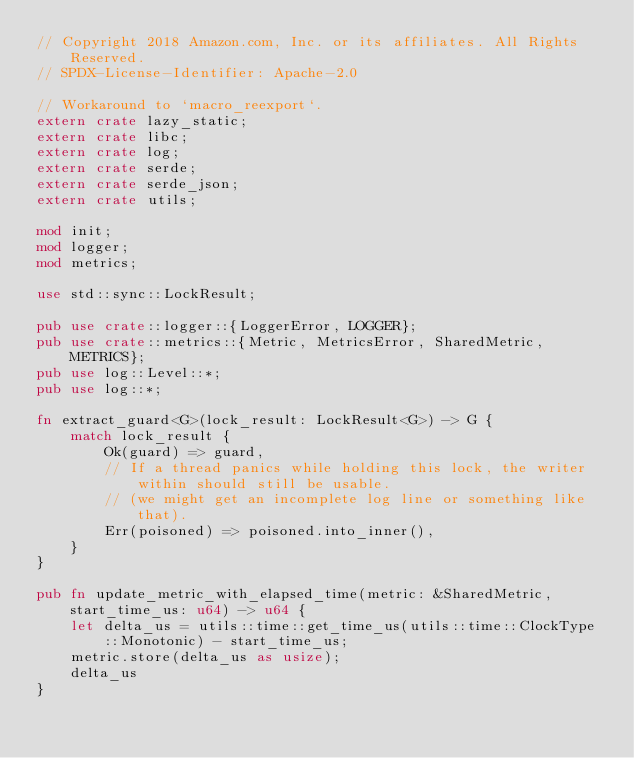Convert code to text. <code><loc_0><loc_0><loc_500><loc_500><_Rust_>// Copyright 2018 Amazon.com, Inc. or its affiliates. All Rights Reserved.
// SPDX-License-Identifier: Apache-2.0

// Workaround to `macro_reexport`.
extern crate lazy_static;
extern crate libc;
extern crate log;
extern crate serde;
extern crate serde_json;
extern crate utils;

mod init;
mod logger;
mod metrics;

use std::sync::LockResult;

pub use crate::logger::{LoggerError, LOGGER};
pub use crate::metrics::{Metric, MetricsError, SharedMetric, METRICS};
pub use log::Level::*;
pub use log::*;

fn extract_guard<G>(lock_result: LockResult<G>) -> G {
    match lock_result {
        Ok(guard) => guard,
        // If a thread panics while holding this lock, the writer within should still be usable.
        // (we might get an incomplete log line or something like that).
        Err(poisoned) => poisoned.into_inner(),
    }
}

pub fn update_metric_with_elapsed_time(metric: &SharedMetric, start_time_us: u64) -> u64 {
    let delta_us = utils::time::get_time_us(utils::time::ClockType::Monotonic) - start_time_us;
    metric.store(delta_us as usize);
    delta_us
}
</code> 